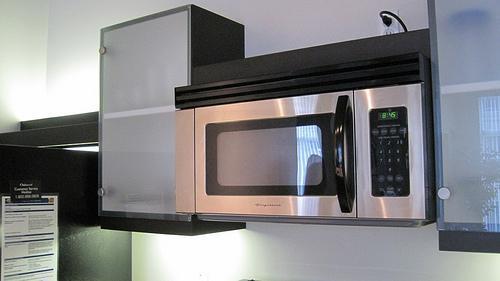How many microwaves?
Give a very brief answer. 1. How many clipboards?
Give a very brief answer. 1. How many cabinets are there?
Give a very brief answer. 2. 